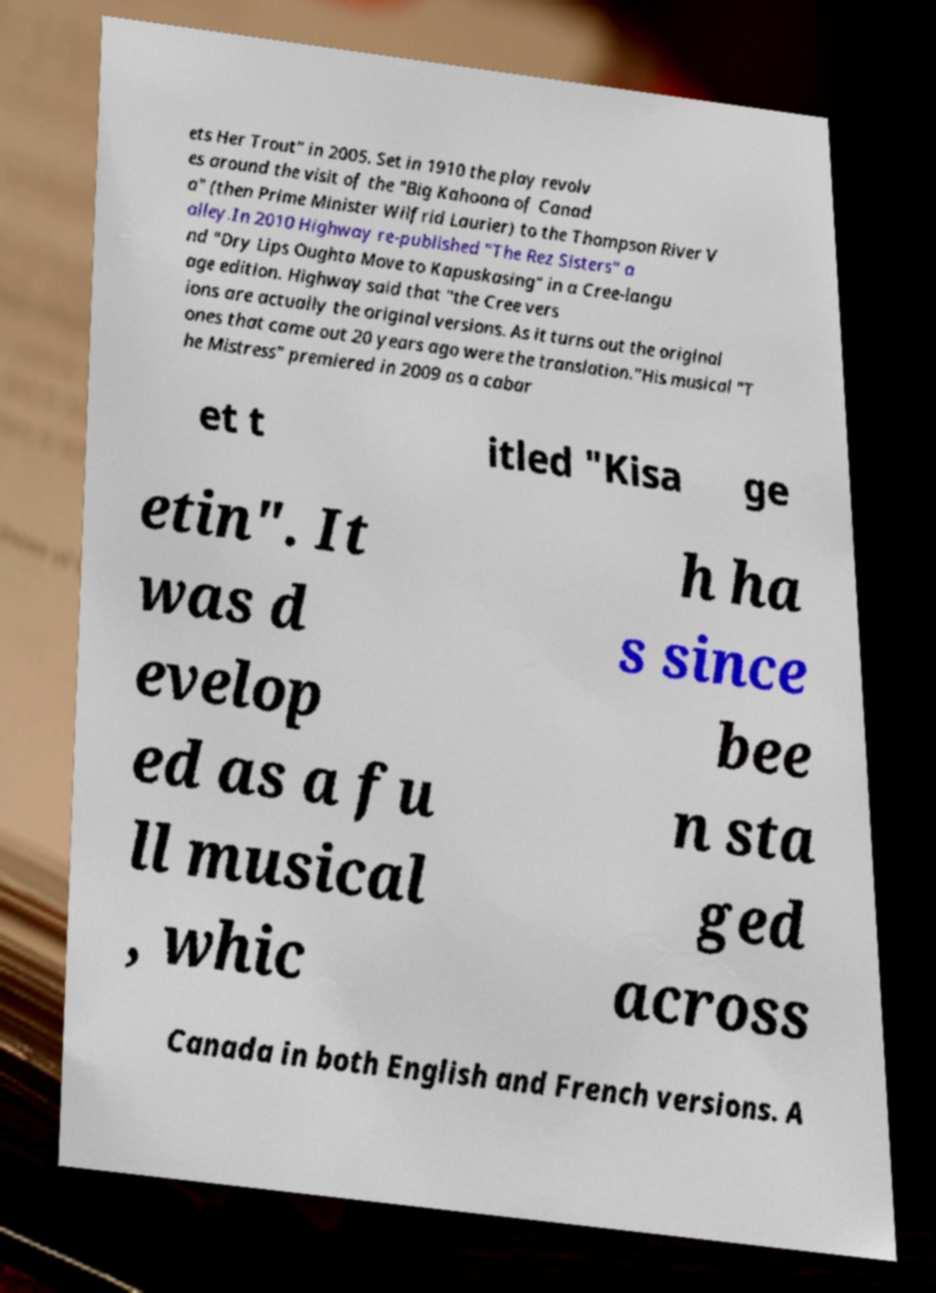What messages or text are displayed in this image? I need them in a readable, typed format. ets Her Trout" in 2005. Set in 1910 the play revolv es around the visit of the "Big Kahoona of Canad a" (then Prime Minister Wilfrid Laurier) to the Thompson River V alley.In 2010 Highway re-published "The Rez Sisters" a nd "Dry Lips Oughta Move to Kapuskasing" in a Cree-langu age edition. Highway said that "the Cree vers ions are actually the original versions. As it turns out the original ones that came out 20 years ago were the translation."His musical "T he Mistress" premiered in 2009 as a cabar et t itled "Kisa ge etin". It was d evelop ed as a fu ll musical , whic h ha s since bee n sta ged across Canada in both English and French versions. A 